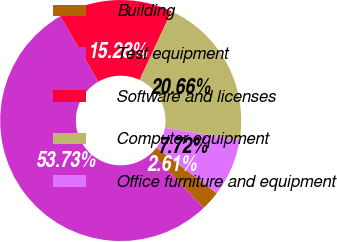Convert chart to OTSL. <chart><loc_0><loc_0><loc_500><loc_500><pie_chart><fcel>Building<fcel>Test equipment<fcel>Software and licenses<fcel>Computer equipment<fcel>Office furniture and equipment<nl><fcel>2.61%<fcel>53.74%<fcel>15.28%<fcel>20.66%<fcel>7.72%<nl></chart> 